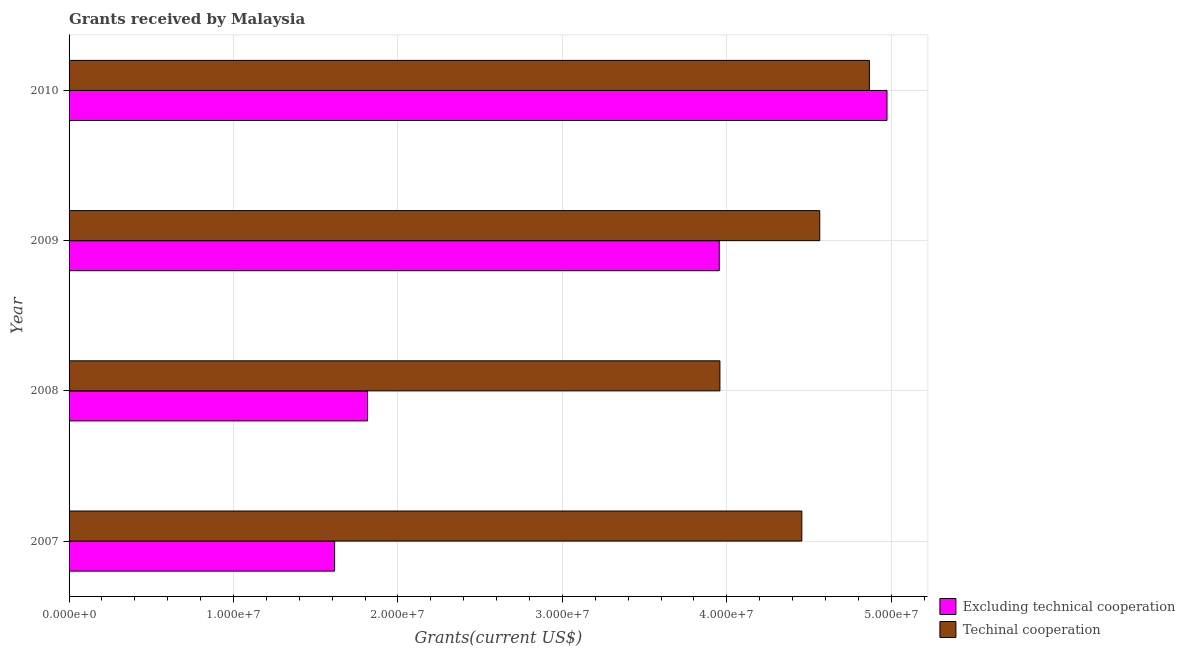How many different coloured bars are there?
Give a very brief answer. 2. Are the number of bars per tick equal to the number of legend labels?
Make the answer very short. Yes. Are the number of bars on each tick of the Y-axis equal?
Give a very brief answer. Yes. In how many cases, is the number of bars for a given year not equal to the number of legend labels?
Provide a succinct answer. 0. What is the amount of grants received(excluding technical cooperation) in 2008?
Make the answer very short. 1.82e+07. Across all years, what is the maximum amount of grants received(excluding technical cooperation)?
Keep it short and to the point. 4.97e+07. Across all years, what is the minimum amount of grants received(excluding technical cooperation)?
Keep it short and to the point. 1.62e+07. In which year was the amount of grants received(including technical cooperation) maximum?
Offer a very short reply. 2010. What is the total amount of grants received(including technical cooperation) in the graph?
Make the answer very short. 1.78e+08. What is the difference between the amount of grants received(excluding technical cooperation) in 2008 and that in 2009?
Keep it short and to the point. -2.14e+07. What is the difference between the amount of grants received(including technical cooperation) in 2009 and the amount of grants received(excluding technical cooperation) in 2007?
Offer a terse response. 2.95e+07. What is the average amount of grants received(excluding technical cooperation) per year?
Provide a short and direct response. 3.09e+07. In the year 2008, what is the difference between the amount of grants received(including technical cooperation) and amount of grants received(excluding technical cooperation)?
Your answer should be compact. 2.14e+07. In how many years, is the amount of grants received(including technical cooperation) greater than 10000000 US$?
Offer a very short reply. 4. What is the ratio of the amount of grants received(excluding technical cooperation) in 2007 to that in 2009?
Keep it short and to the point. 0.41. Is the amount of grants received(excluding technical cooperation) in 2008 less than that in 2009?
Keep it short and to the point. Yes. Is the difference between the amount of grants received(including technical cooperation) in 2007 and 2009 greater than the difference between the amount of grants received(excluding technical cooperation) in 2007 and 2009?
Give a very brief answer. Yes. What is the difference between the highest and the second highest amount of grants received(including technical cooperation)?
Offer a terse response. 3.02e+06. What is the difference between the highest and the lowest amount of grants received(excluding technical cooperation)?
Keep it short and to the point. 3.36e+07. In how many years, is the amount of grants received(including technical cooperation) greater than the average amount of grants received(including technical cooperation) taken over all years?
Offer a terse response. 2. What does the 2nd bar from the top in 2009 represents?
Provide a short and direct response. Excluding technical cooperation. What does the 1st bar from the bottom in 2010 represents?
Ensure brevity in your answer.  Excluding technical cooperation. How many bars are there?
Offer a very short reply. 8. Are the values on the major ticks of X-axis written in scientific E-notation?
Ensure brevity in your answer.  Yes. Does the graph contain grids?
Make the answer very short. Yes. Where does the legend appear in the graph?
Ensure brevity in your answer.  Bottom right. How many legend labels are there?
Offer a very short reply. 2. How are the legend labels stacked?
Provide a succinct answer. Vertical. What is the title of the graph?
Your answer should be very brief. Grants received by Malaysia. Does "Urban Population" appear as one of the legend labels in the graph?
Offer a terse response. No. What is the label or title of the X-axis?
Give a very brief answer. Grants(current US$). What is the label or title of the Y-axis?
Give a very brief answer. Year. What is the Grants(current US$) in Excluding technical cooperation in 2007?
Provide a succinct answer. 1.62e+07. What is the Grants(current US$) in Techinal cooperation in 2007?
Give a very brief answer. 4.46e+07. What is the Grants(current US$) of Excluding technical cooperation in 2008?
Your response must be concise. 1.82e+07. What is the Grants(current US$) in Techinal cooperation in 2008?
Ensure brevity in your answer.  3.96e+07. What is the Grants(current US$) of Excluding technical cooperation in 2009?
Ensure brevity in your answer.  3.95e+07. What is the Grants(current US$) in Techinal cooperation in 2009?
Keep it short and to the point. 4.56e+07. What is the Grants(current US$) of Excluding technical cooperation in 2010?
Ensure brevity in your answer.  4.97e+07. What is the Grants(current US$) of Techinal cooperation in 2010?
Ensure brevity in your answer.  4.87e+07. Across all years, what is the maximum Grants(current US$) of Excluding technical cooperation?
Offer a very short reply. 4.97e+07. Across all years, what is the maximum Grants(current US$) in Techinal cooperation?
Offer a very short reply. 4.87e+07. Across all years, what is the minimum Grants(current US$) in Excluding technical cooperation?
Your answer should be compact. 1.62e+07. Across all years, what is the minimum Grants(current US$) in Techinal cooperation?
Make the answer very short. 3.96e+07. What is the total Grants(current US$) in Excluding technical cooperation in the graph?
Offer a terse response. 1.24e+08. What is the total Grants(current US$) of Techinal cooperation in the graph?
Provide a succinct answer. 1.78e+08. What is the difference between the Grants(current US$) of Techinal cooperation in 2007 and that in 2008?
Offer a terse response. 4.98e+06. What is the difference between the Grants(current US$) in Excluding technical cooperation in 2007 and that in 2009?
Keep it short and to the point. -2.34e+07. What is the difference between the Grants(current US$) of Techinal cooperation in 2007 and that in 2009?
Provide a short and direct response. -1.09e+06. What is the difference between the Grants(current US$) in Excluding technical cooperation in 2007 and that in 2010?
Provide a succinct answer. -3.36e+07. What is the difference between the Grants(current US$) of Techinal cooperation in 2007 and that in 2010?
Offer a terse response. -4.11e+06. What is the difference between the Grants(current US$) of Excluding technical cooperation in 2008 and that in 2009?
Give a very brief answer. -2.14e+07. What is the difference between the Grants(current US$) of Techinal cooperation in 2008 and that in 2009?
Your answer should be compact. -6.07e+06. What is the difference between the Grants(current US$) of Excluding technical cooperation in 2008 and that in 2010?
Keep it short and to the point. -3.16e+07. What is the difference between the Grants(current US$) of Techinal cooperation in 2008 and that in 2010?
Your answer should be compact. -9.09e+06. What is the difference between the Grants(current US$) in Excluding technical cooperation in 2009 and that in 2010?
Ensure brevity in your answer.  -1.02e+07. What is the difference between the Grants(current US$) of Techinal cooperation in 2009 and that in 2010?
Ensure brevity in your answer.  -3.02e+06. What is the difference between the Grants(current US$) of Excluding technical cooperation in 2007 and the Grants(current US$) of Techinal cooperation in 2008?
Make the answer very short. -2.34e+07. What is the difference between the Grants(current US$) in Excluding technical cooperation in 2007 and the Grants(current US$) in Techinal cooperation in 2009?
Your answer should be very brief. -2.95e+07. What is the difference between the Grants(current US$) of Excluding technical cooperation in 2007 and the Grants(current US$) of Techinal cooperation in 2010?
Offer a terse response. -3.25e+07. What is the difference between the Grants(current US$) of Excluding technical cooperation in 2008 and the Grants(current US$) of Techinal cooperation in 2009?
Your answer should be compact. -2.75e+07. What is the difference between the Grants(current US$) of Excluding technical cooperation in 2008 and the Grants(current US$) of Techinal cooperation in 2010?
Offer a terse response. -3.05e+07. What is the difference between the Grants(current US$) of Excluding technical cooperation in 2009 and the Grants(current US$) of Techinal cooperation in 2010?
Your answer should be compact. -9.13e+06. What is the average Grants(current US$) in Excluding technical cooperation per year?
Your response must be concise. 3.09e+07. What is the average Grants(current US$) of Techinal cooperation per year?
Provide a short and direct response. 4.46e+07. In the year 2007, what is the difference between the Grants(current US$) in Excluding technical cooperation and Grants(current US$) in Techinal cooperation?
Give a very brief answer. -2.84e+07. In the year 2008, what is the difference between the Grants(current US$) of Excluding technical cooperation and Grants(current US$) of Techinal cooperation?
Give a very brief answer. -2.14e+07. In the year 2009, what is the difference between the Grants(current US$) in Excluding technical cooperation and Grants(current US$) in Techinal cooperation?
Your answer should be compact. -6.11e+06. In the year 2010, what is the difference between the Grants(current US$) in Excluding technical cooperation and Grants(current US$) in Techinal cooperation?
Keep it short and to the point. 1.07e+06. What is the ratio of the Grants(current US$) of Excluding technical cooperation in 2007 to that in 2008?
Your response must be concise. 0.89. What is the ratio of the Grants(current US$) of Techinal cooperation in 2007 to that in 2008?
Your response must be concise. 1.13. What is the ratio of the Grants(current US$) of Excluding technical cooperation in 2007 to that in 2009?
Your answer should be very brief. 0.41. What is the ratio of the Grants(current US$) of Techinal cooperation in 2007 to that in 2009?
Keep it short and to the point. 0.98. What is the ratio of the Grants(current US$) in Excluding technical cooperation in 2007 to that in 2010?
Keep it short and to the point. 0.32. What is the ratio of the Grants(current US$) of Techinal cooperation in 2007 to that in 2010?
Offer a very short reply. 0.92. What is the ratio of the Grants(current US$) in Excluding technical cooperation in 2008 to that in 2009?
Offer a terse response. 0.46. What is the ratio of the Grants(current US$) in Techinal cooperation in 2008 to that in 2009?
Your answer should be compact. 0.87. What is the ratio of the Grants(current US$) in Excluding technical cooperation in 2008 to that in 2010?
Make the answer very short. 0.36. What is the ratio of the Grants(current US$) of Techinal cooperation in 2008 to that in 2010?
Ensure brevity in your answer.  0.81. What is the ratio of the Grants(current US$) in Excluding technical cooperation in 2009 to that in 2010?
Provide a succinct answer. 0.79. What is the ratio of the Grants(current US$) of Techinal cooperation in 2009 to that in 2010?
Your response must be concise. 0.94. What is the difference between the highest and the second highest Grants(current US$) in Excluding technical cooperation?
Make the answer very short. 1.02e+07. What is the difference between the highest and the second highest Grants(current US$) in Techinal cooperation?
Your answer should be compact. 3.02e+06. What is the difference between the highest and the lowest Grants(current US$) in Excluding technical cooperation?
Provide a succinct answer. 3.36e+07. What is the difference between the highest and the lowest Grants(current US$) in Techinal cooperation?
Make the answer very short. 9.09e+06. 